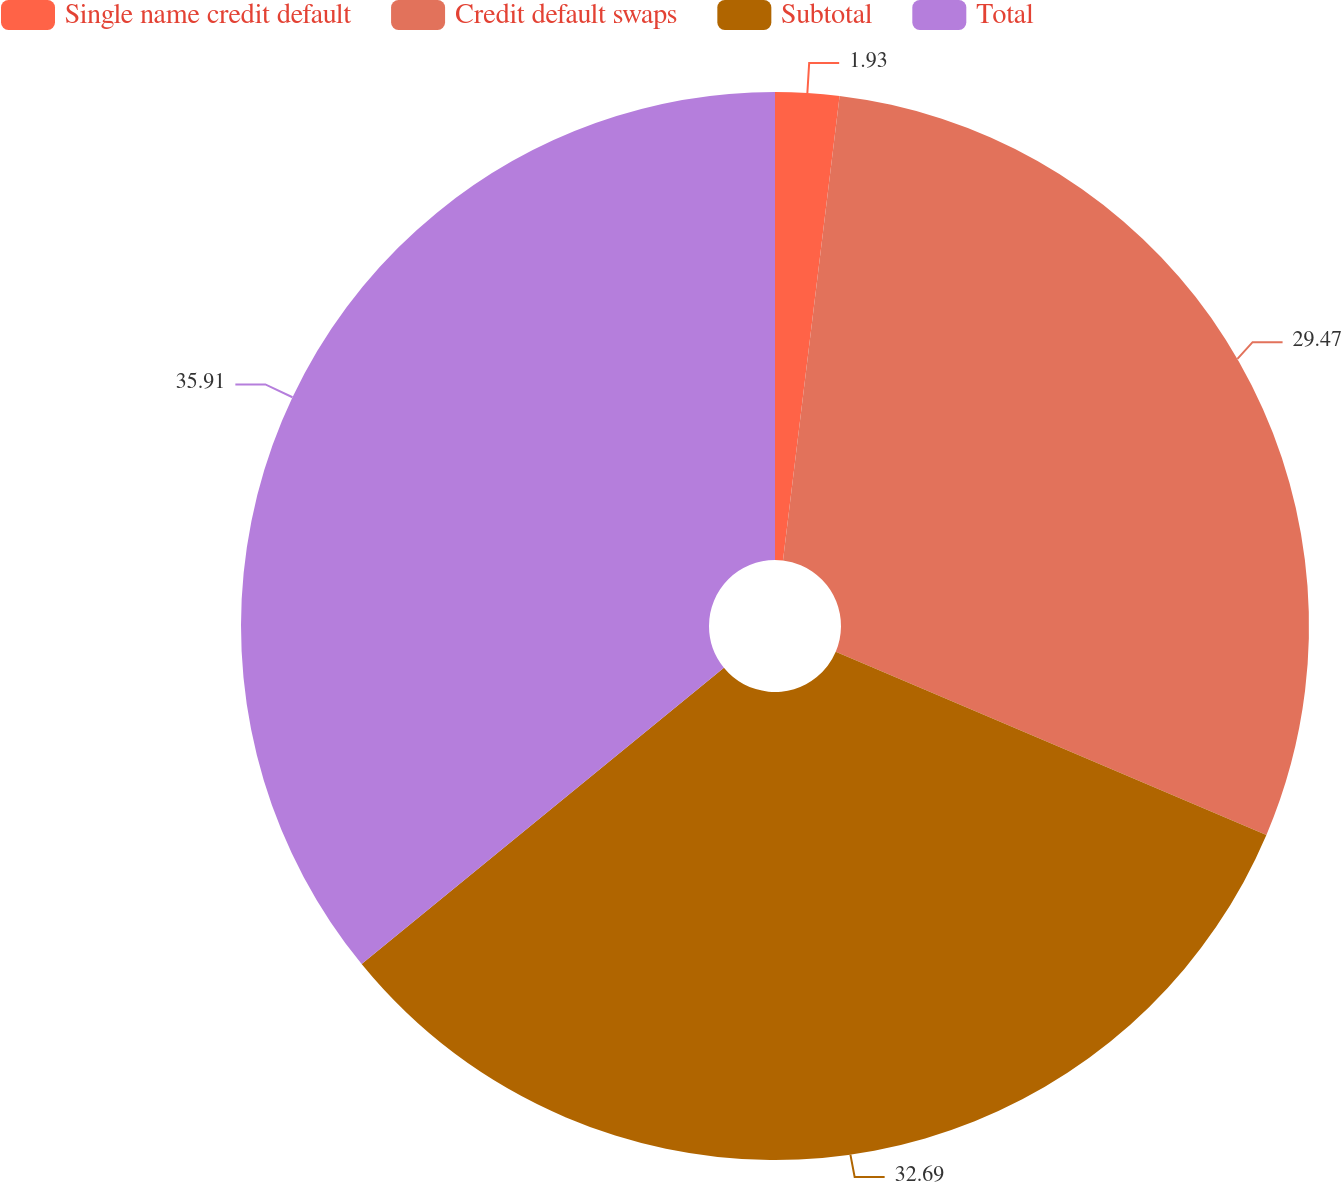Convert chart to OTSL. <chart><loc_0><loc_0><loc_500><loc_500><pie_chart><fcel>Single name credit default<fcel>Credit default swaps<fcel>Subtotal<fcel>Total<nl><fcel>1.93%<fcel>29.47%<fcel>32.69%<fcel>35.91%<nl></chart> 